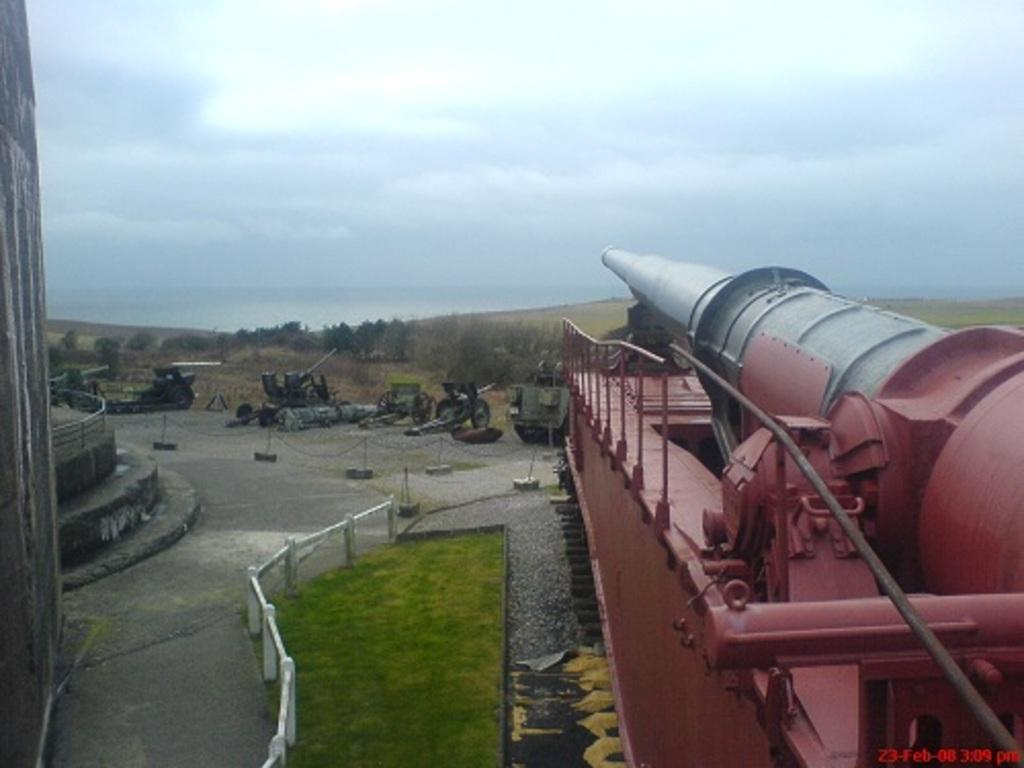What objects are on the ground in the image? There are cannons on the ground in the image. What type of terrain is visible in the image? There is grass visible in the image. What architectural feature can be seen in the image? There are railings in the image. What can be seen in the background of the image? There are trees in the background of the image. How would you describe the weather in the image? The sky is cloudy in the image. Who is the creator of the dirt visible in the image? There is no dirt visible in the image, and therefore no creator can be identified. What type of mask is being worn by the trees in the background? There are no masks present in the image, and the trees do not have the ability to wear masks. 